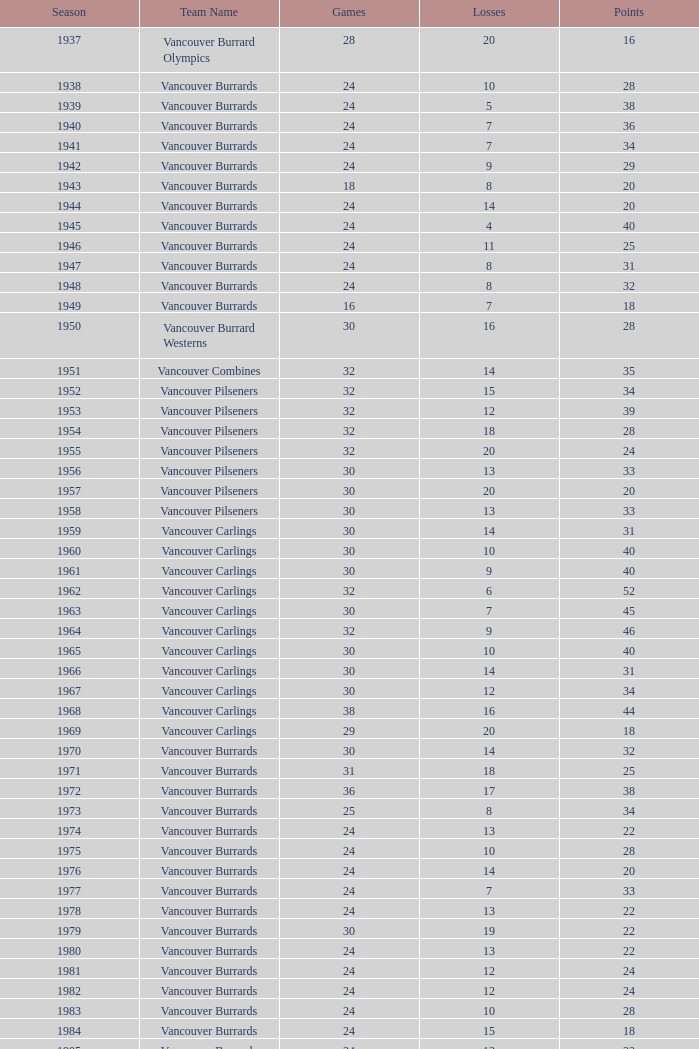What's the total number of points when the vancouver carlings have fewer than 12 losses and more than 32 games? 0.0. 